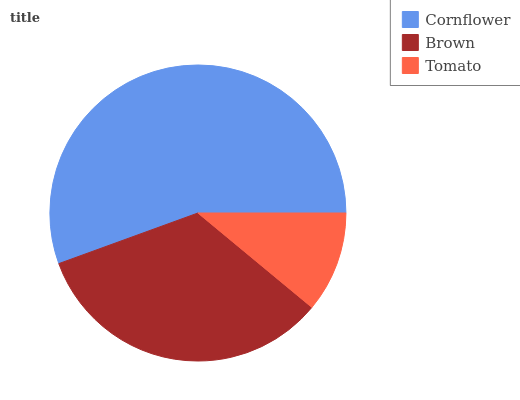Is Tomato the minimum?
Answer yes or no. Yes. Is Cornflower the maximum?
Answer yes or no. Yes. Is Brown the minimum?
Answer yes or no. No. Is Brown the maximum?
Answer yes or no. No. Is Cornflower greater than Brown?
Answer yes or no. Yes. Is Brown less than Cornflower?
Answer yes or no. Yes. Is Brown greater than Cornflower?
Answer yes or no. No. Is Cornflower less than Brown?
Answer yes or no. No. Is Brown the high median?
Answer yes or no. Yes. Is Brown the low median?
Answer yes or no. Yes. Is Cornflower the high median?
Answer yes or no. No. Is Cornflower the low median?
Answer yes or no. No. 